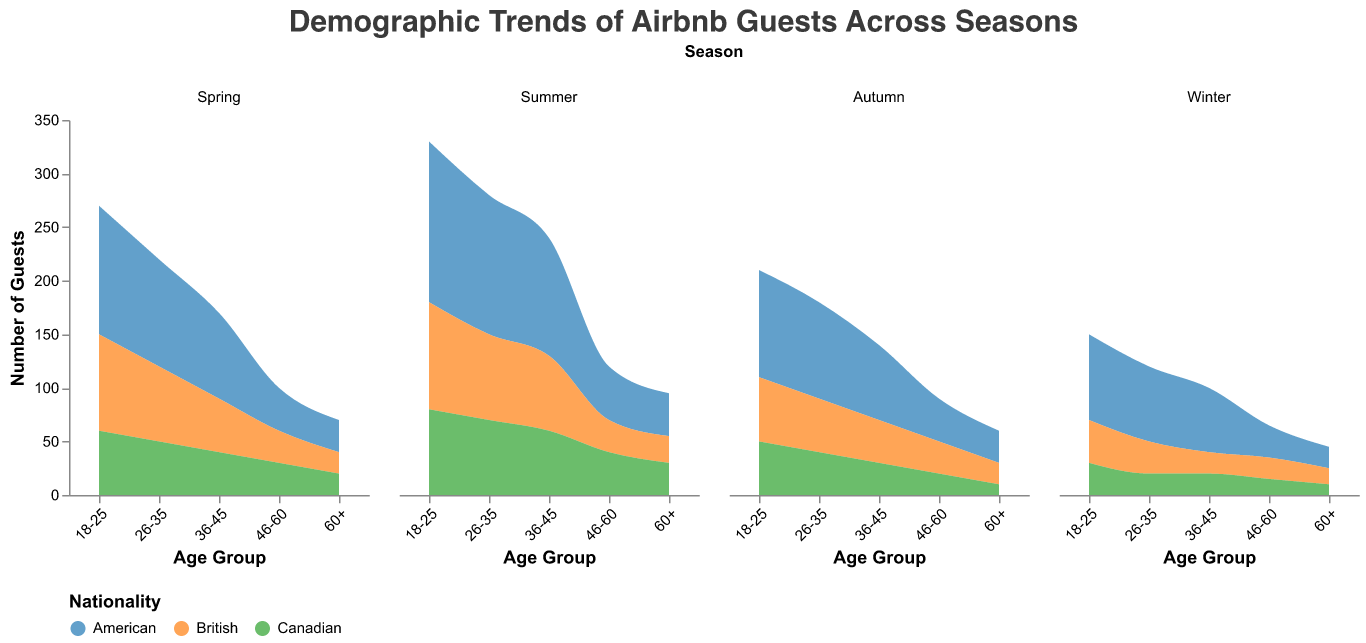What is the title of the chart? The title is displayed at the top of the figure.
Answer: Demographic Trends of Airbnb Guests Across Seasons Which nationality has the most guests in Summer? By examining the colors representing nationalities in the Summer subplot, it is evident that American guests, represented by the largest area, have the most guests.
Answer: American Which age group has the highest number of Canadian guests in Spring? The age group with the highest number of Canadian guests in Spring can be found by identifying the largest area in the corresponding section of the plot.
Answer: 18-25 Is the number of American guests ages 36-45 higher in Summer or Winter? Compare the areas representing American guests ages 36-45 between Summer and Winter subplots. The area is larger in the Summer subplot.
Answer: Summer How does the number of British guests ages 18-25 in Autumn compare to Winter? Compare the sizes of the areas representing British guests ages 18-25 between the Autumn and Winter subplots. The area in Autumn is larger.
Answer: Autumn What's the total number of Canadian guests in Autumn across all age groups? Sum the number of Canadian guests in Autumn across all age groups: 50 (18-25) + 40 (26-35) + 30 (36-45) + 20 (46-60) + 10 (60+).
Answer: 150 Which season has the least number of 60+ guests overall? Compare the total number of guests aged 60+ across all nationalities in each season. Winter has the lowest cumulative area for guests aged 60+.
Answer: Winter How does the number of British guests ages 26-35 in Spring compare to Summer? Compare the sizes of the areas representing British guests ages 26-35 between Spring and Summer subplots. The area in Spring is smaller.
Answer: Summer What is the predominant age group of American guests in Winter? Identify the age group with the largest area for American guests in the Winter subplot. Ages 18-25 occupy the largest area.
Answer: 18-25 Which nationality has the highest variability in guest numbers across all seasons? Observe the changes in area sizes across all seasons for each nationality. American guests show the highest variability, with significant changes in numbers.
Answer: American 